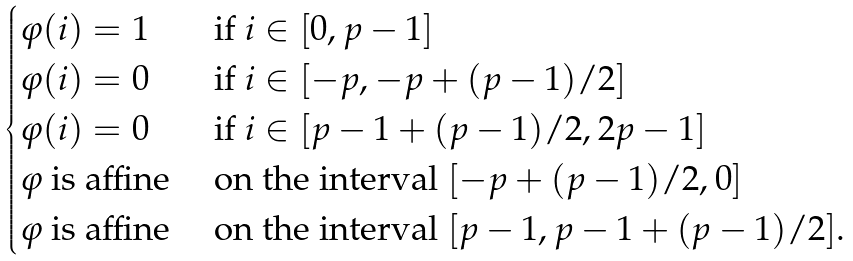Convert formula to latex. <formula><loc_0><loc_0><loc_500><loc_500>\begin{cases} \varphi ( i ) = 1 & \text { if } i \in [ 0 , p - 1 ] \\ \varphi ( i ) = 0 & \text { if } i \in [ - p , - p + ( p - 1 ) / 2 ] \\ \varphi ( i ) = 0 & \text { if } i \in [ p - 1 + ( p - 1 ) / 2 , 2 p - 1 ] \\ \varphi \text { is affine} & \text { on the interval } [ - p + ( p - 1 ) / 2 , 0 ] \\ \varphi \text { is affine} & \text { on the interval } [ p - 1 , p - 1 + ( p - 1 ) / 2 ] . \end{cases}</formula> 